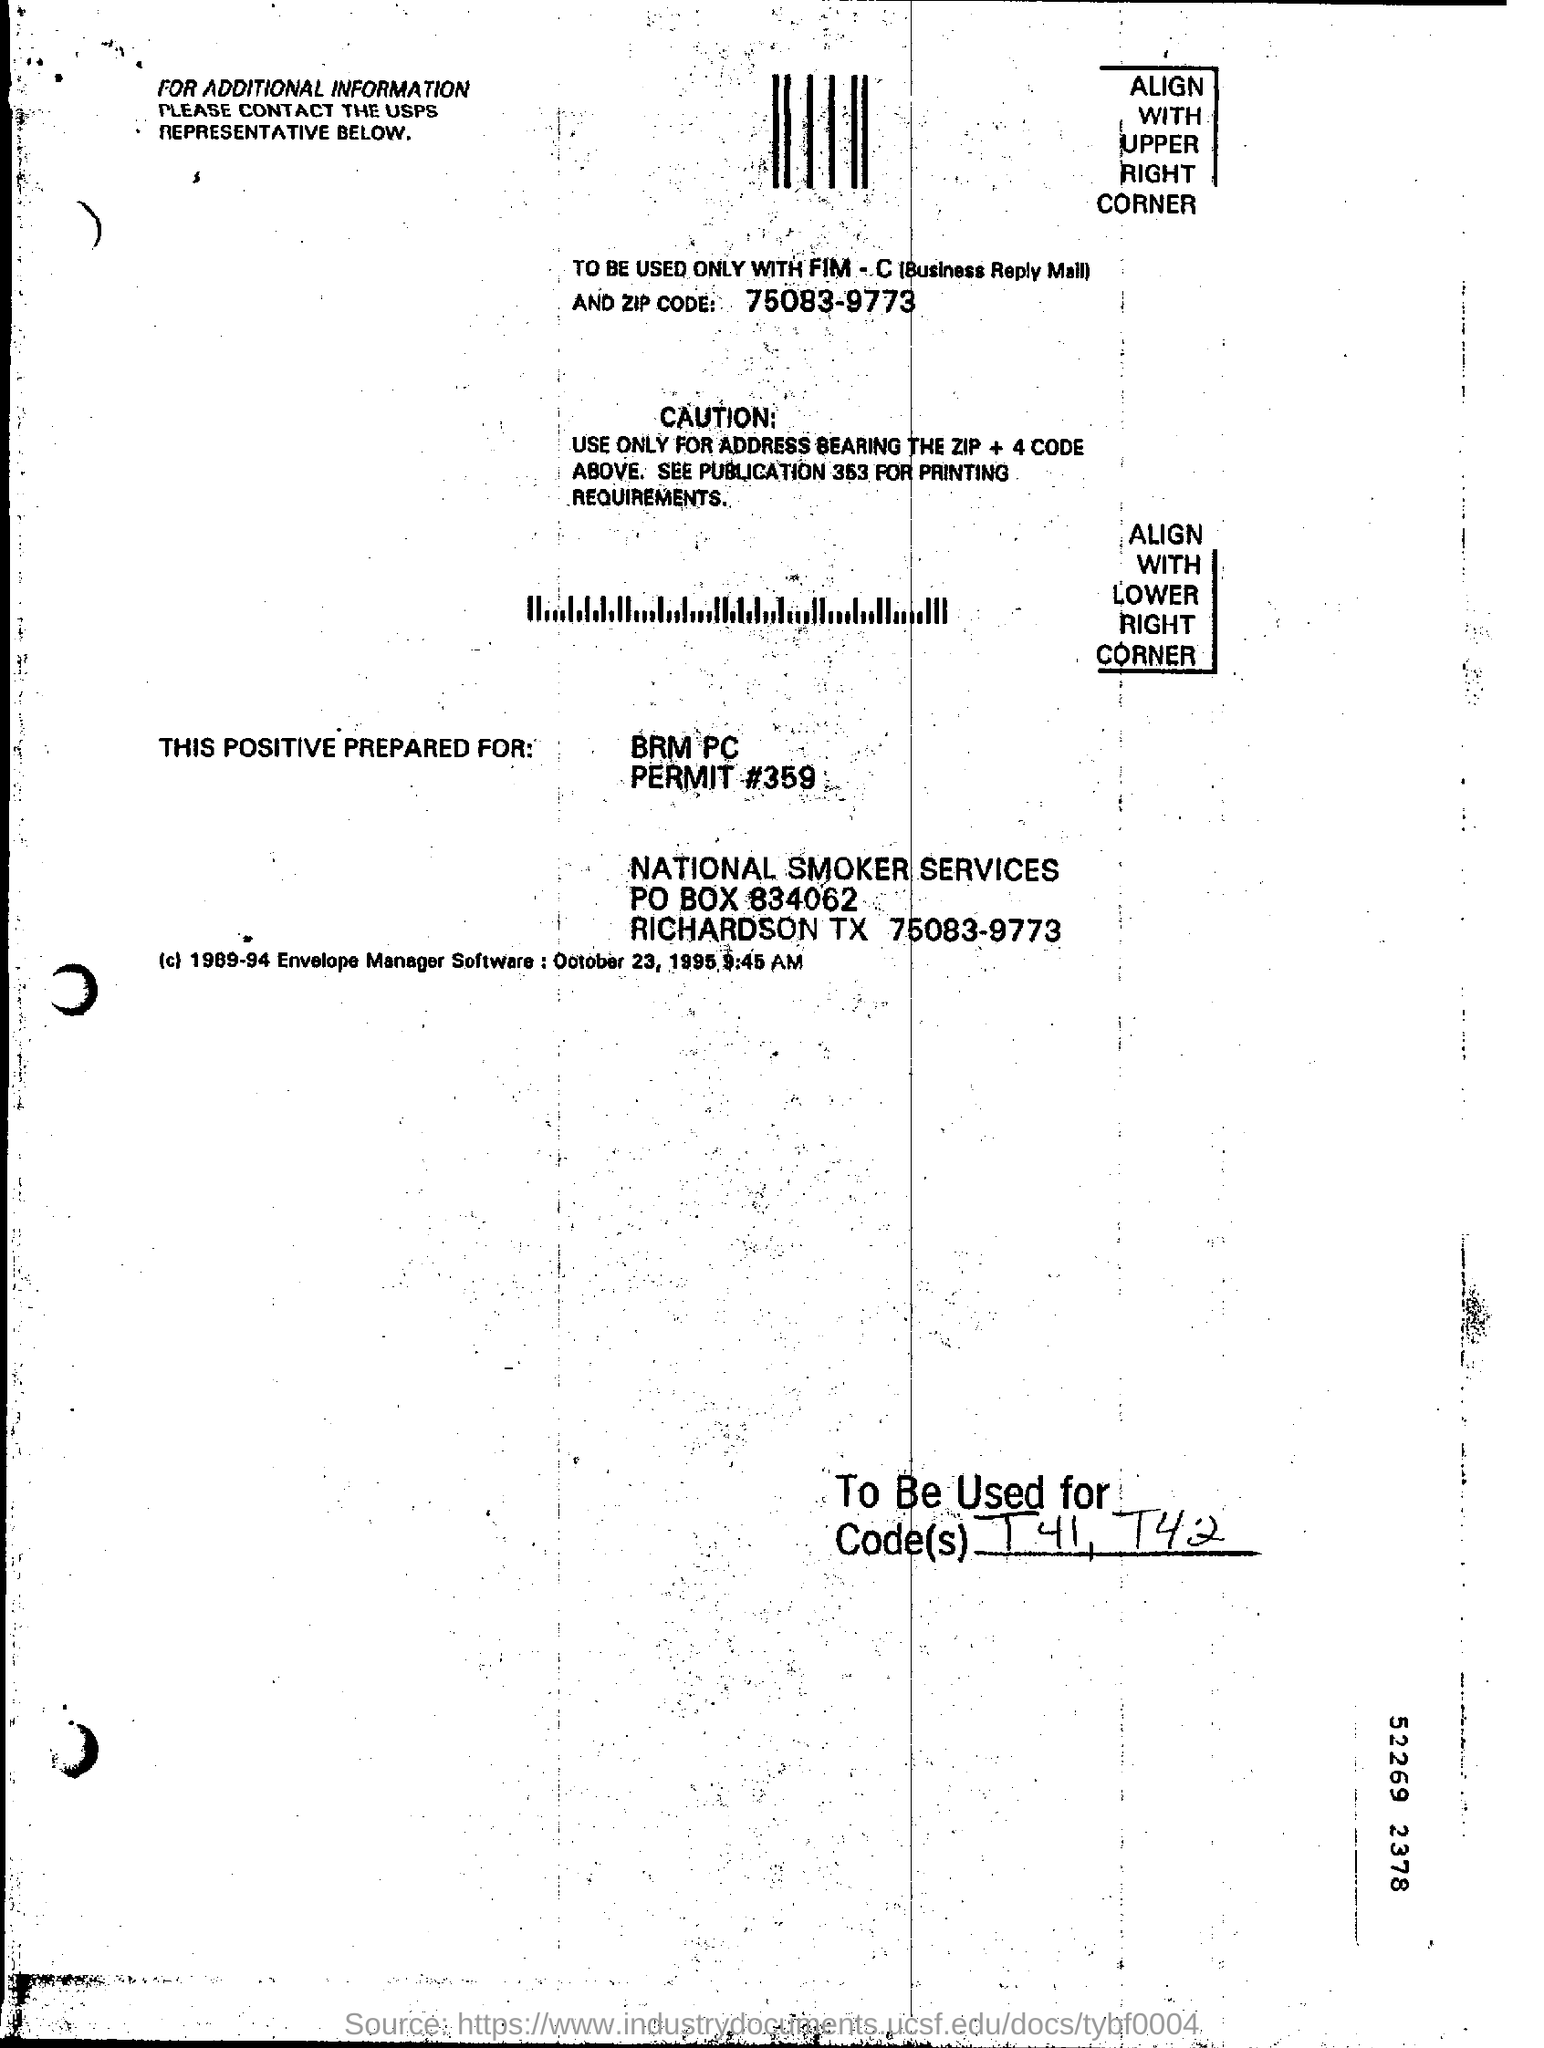What is the permit#?
Provide a succinct answer. 359. What is the zip code mentioned?
Ensure brevity in your answer.  75083-9773. Which publication should be refered for printing requirements?
Provide a succinct answer. Publication 363. Should be used for address bearing which code?
Keep it short and to the point. ZIP + 4 Code. 